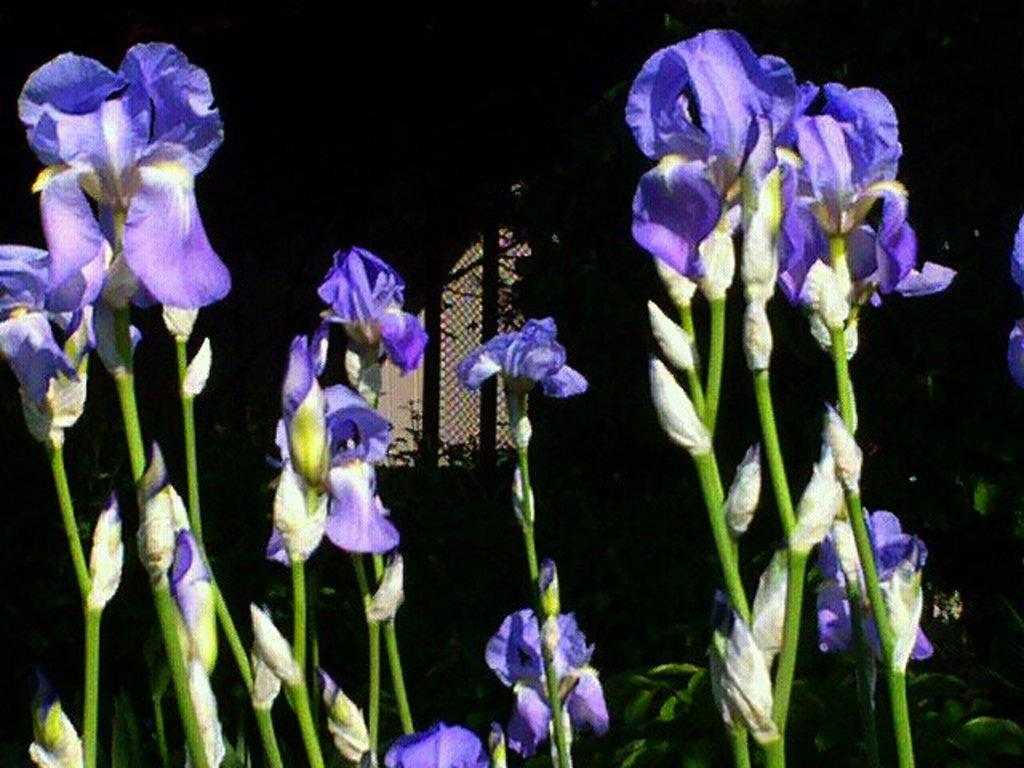What type of living organisms can be seen in the image? Plants and flowers are visible in the image. Can you describe the flowers in the image? The flowers in the image are part of the plants and add color and beauty to the scene. What type of power source can be seen in the image? There is no power source visible in the image; it features plants and flowers. Where is the playground located in the image? There is no playground present in the image; it features plants and flowers. 